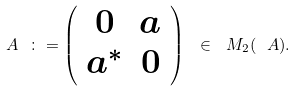Convert formula to latex. <formula><loc_0><loc_0><loc_500><loc_500>A \ \colon = \left ( \begin{array} { c c } 0 & a \\ a ^ { * } & 0 \end{array} \right ) \ \in \ M _ { 2 } ( \ A ) .</formula> 